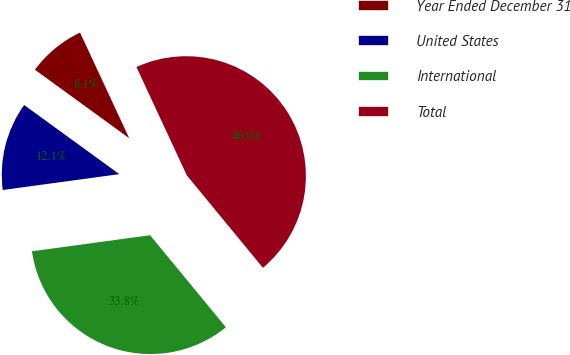Convert chart to OTSL. <chart><loc_0><loc_0><loc_500><loc_500><pie_chart><fcel>Year Ended December 31<fcel>United States<fcel>International<fcel>Total<nl><fcel>8.07%<fcel>12.15%<fcel>33.81%<fcel>45.97%<nl></chart> 